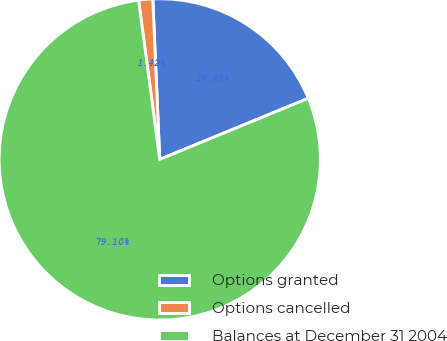<chart> <loc_0><loc_0><loc_500><loc_500><pie_chart><fcel>Options granted<fcel>Options cancelled<fcel>Balances at December 31 2004<nl><fcel>19.48%<fcel>1.42%<fcel>79.1%<nl></chart> 